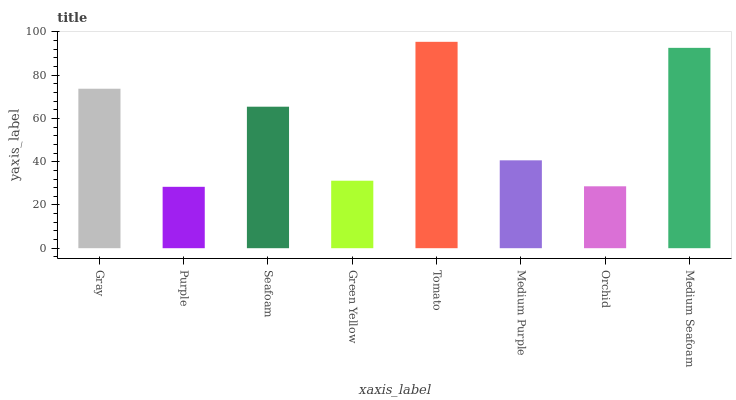Is Purple the minimum?
Answer yes or no. Yes. Is Tomato the maximum?
Answer yes or no. Yes. Is Seafoam the minimum?
Answer yes or no. No. Is Seafoam the maximum?
Answer yes or no. No. Is Seafoam greater than Purple?
Answer yes or no. Yes. Is Purple less than Seafoam?
Answer yes or no. Yes. Is Purple greater than Seafoam?
Answer yes or no. No. Is Seafoam less than Purple?
Answer yes or no. No. Is Seafoam the high median?
Answer yes or no. Yes. Is Medium Purple the low median?
Answer yes or no. Yes. Is Green Yellow the high median?
Answer yes or no. No. Is Orchid the low median?
Answer yes or no. No. 